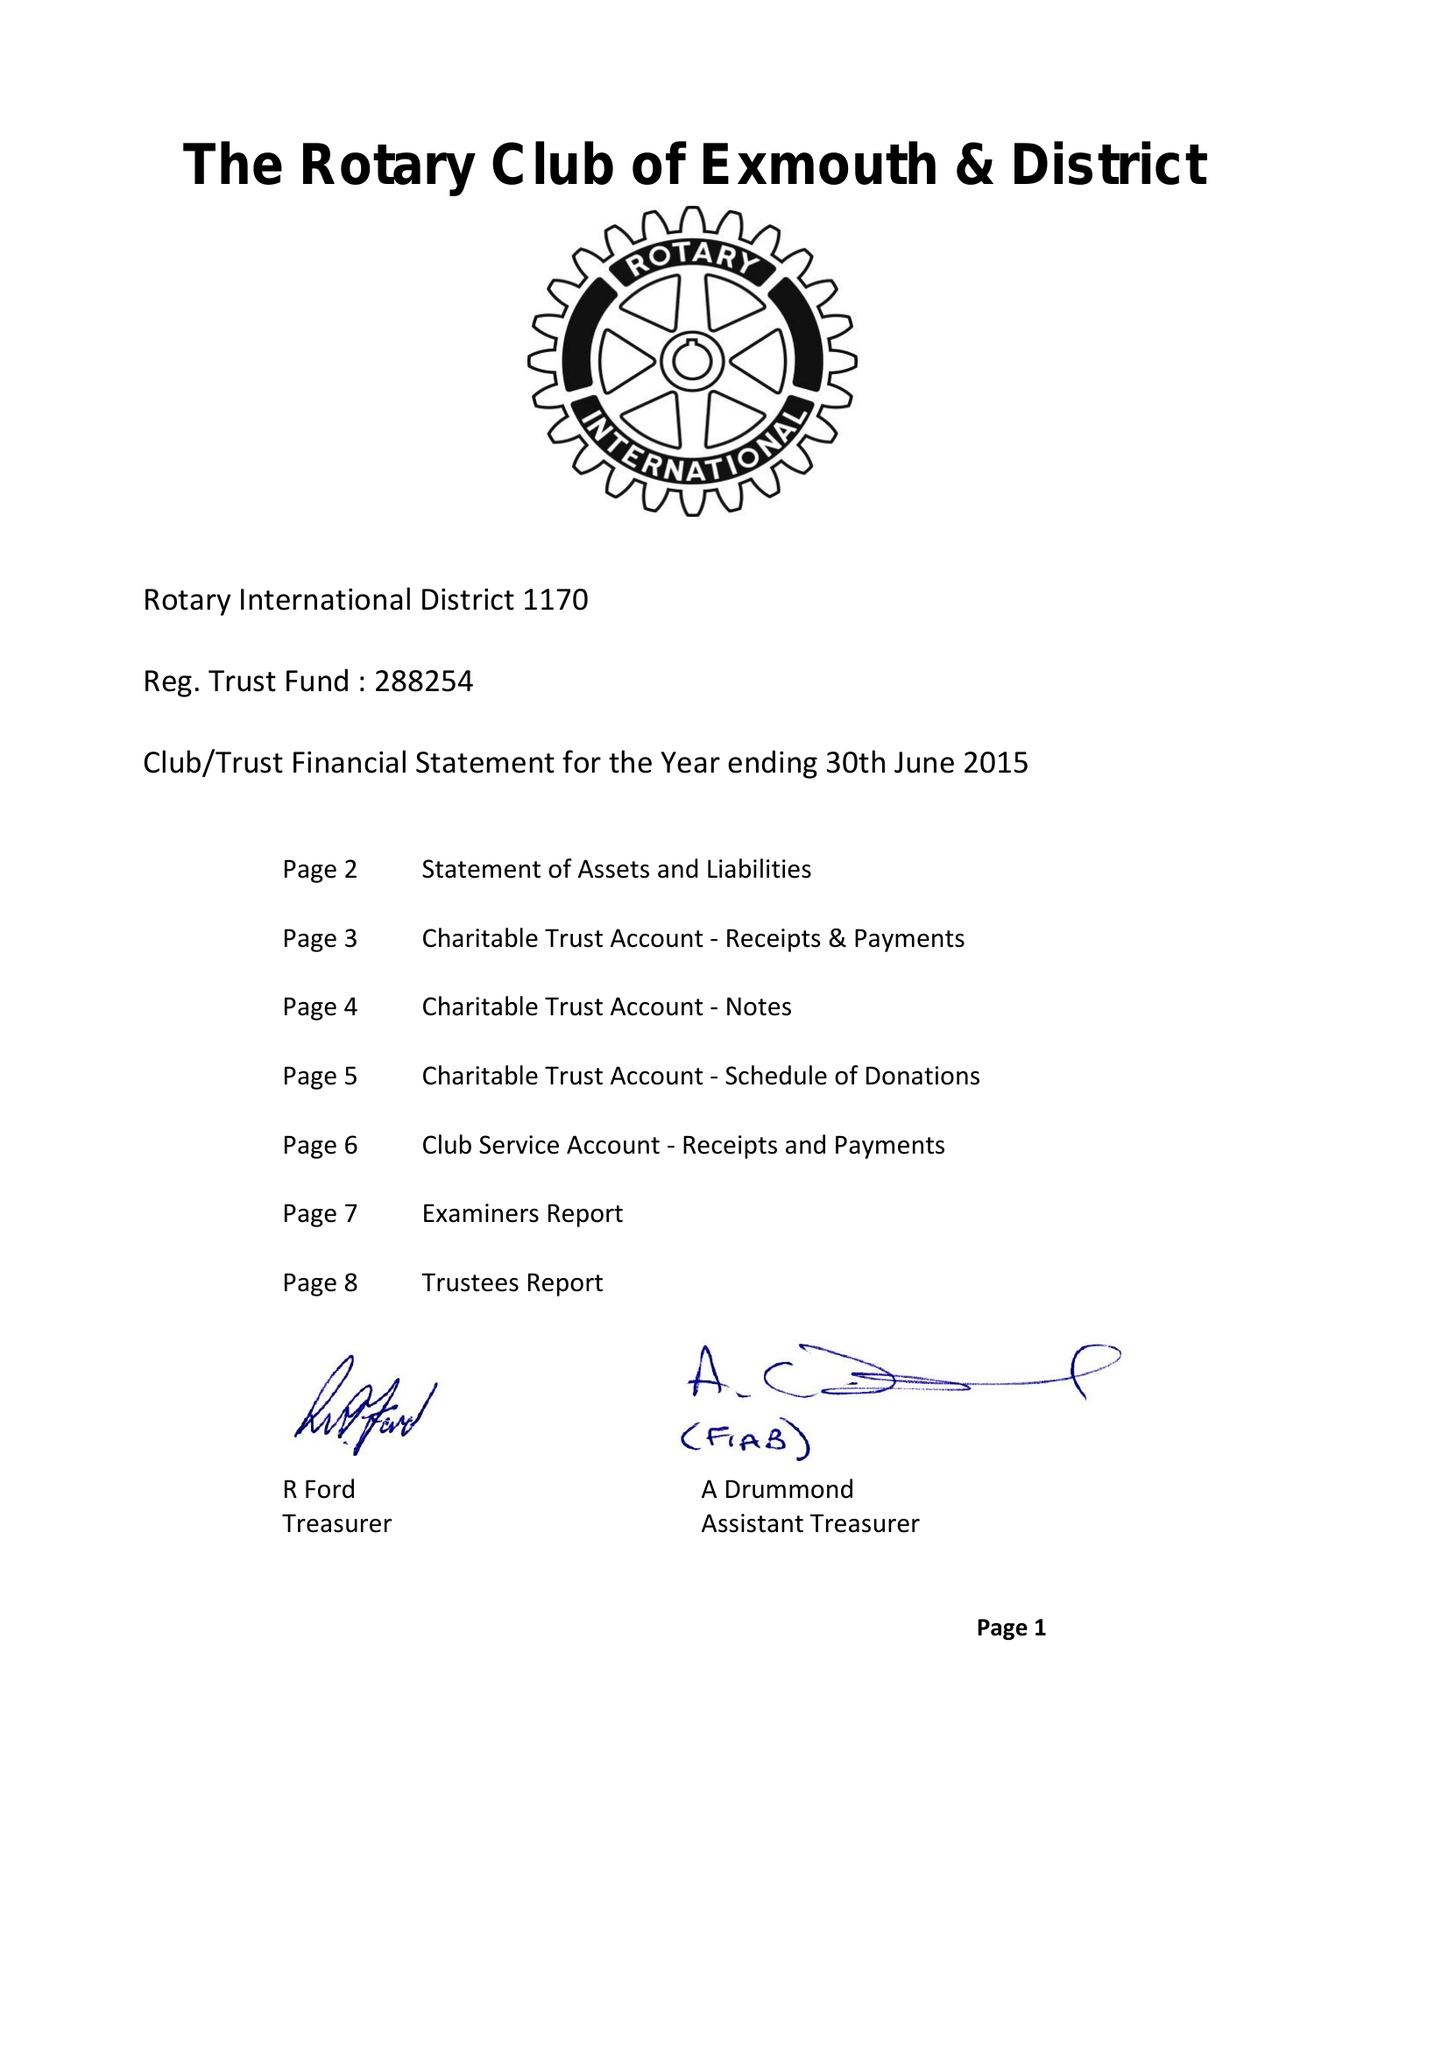What is the value for the income_annually_in_british_pounds?
Answer the question using a single word or phrase. 56534.00 